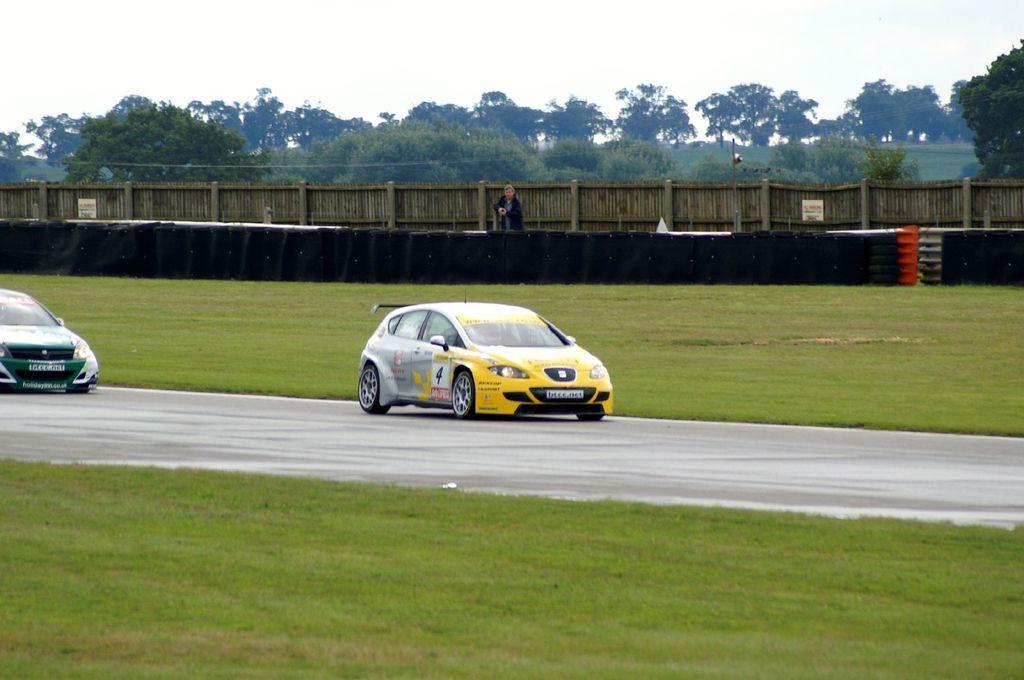In one or two sentences, can you explain what this image depicts? In this picture we can see grass at the bottom, there are two cars traveling on the road, in the background we can see fencing and trees, there is a person standing in the middle, we can see the sky at the top of the picture. 